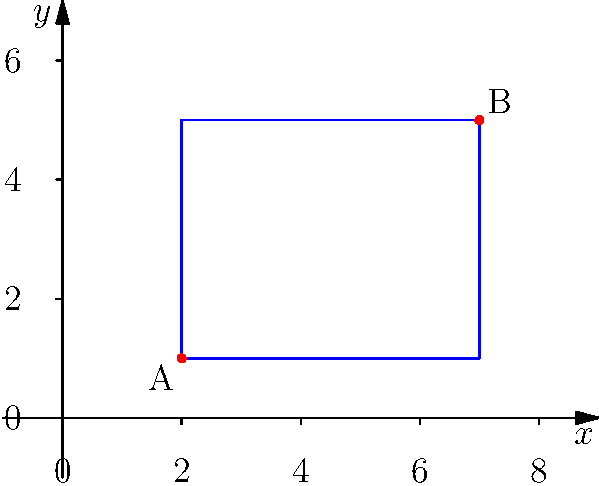At Pine Bluff Aquatic Center, a new rectangular swimming pool is being planned. On the coordinate plane, the pool is represented by a rectangle with opposite corners at points A(2,1) and B(7,5). What is the area of the swimming pool in square units? To find the area of the rectangular swimming pool, we need to follow these steps:

1) First, we need to find the length and width of the rectangle.

2) The length is the difference between the x-coordinates of points A and B:
   Length = $7 - 2 = 5$ units

3) The width is the difference between the y-coordinates of points A and B:
   Width = $5 - 1 = 4$ units

4) The area of a rectangle is given by the formula:
   Area = length $\times$ width

5) Substituting our values:
   Area = $5 \times 4 = 20$ square units

Therefore, the area of the swimming pool is 20 square units.
Answer: 20 square units 